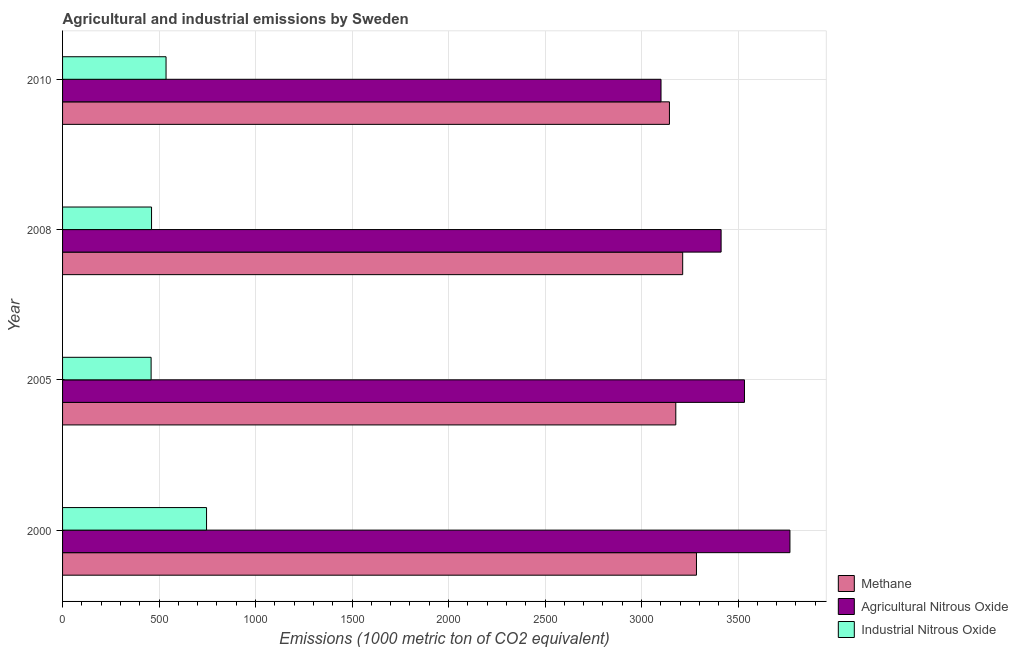How many different coloured bars are there?
Give a very brief answer. 3. How many bars are there on the 4th tick from the top?
Provide a succinct answer. 3. In how many cases, is the number of bars for a given year not equal to the number of legend labels?
Keep it short and to the point. 0. What is the amount of methane emissions in 2000?
Provide a succinct answer. 3284.7. Across all years, what is the maximum amount of industrial nitrous oxide emissions?
Provide a succinct answer. 746.1. Across all years, what is the minimum amount of methane emissions?
Offer a terse response. 3144.6. In which year was the amount of methane emissions maximum?
Offer a terse response. 2000. What is the total amount of agricultural nitrous oxide emissions in the graph?
Keep it short and to the point. 1.38e+04. What is the difference between the amount of industrial nitrous oxide emissions in 2008 and that in 2010?
Provide a short and direct response. -75.1. What is the difference between the amount of methane emissions in 2000 and the amount of agricultural nitrous oxide emissions in 2005?
Provide a succinct answer. -248.7. What is the average amount of methane emissions per year?
Provide a short and direct response. 3205.05. In the year 2010, what is the difference between the amount of industrial nitrous oxide emissions and amount of agricultural nitrous oxide emissions?
Your answer should be very brief. -2564.8. What is the ratio of the amount of agricultural nitrous oxide emissions in 2008 to that in 2010?
Offer a very short reply. 1.1. Is the amount of methane emissions in 2005 less than that in 2010?
Keep it short and to the point. No. Is the difference between the amount of industrial nitrous oxide emissions in 2005 and 2010 greater than the difference between the amount of agricultural nitrous oxide emissions in 2005 and 2010?
Your response must be concise. No. What is the difference between the highest and the second highest amount of industrial nitrous oxide emissions?
Ensure brevity in your answer.  209.9. What is the difference between the highest and the lowest amount of industrial nitrous oxide emissions?
Your answer should be very brief. 287.3. In how many years, is the amount of methane emissions greater than the average amount of methane emissions taken over all years?
Keep it short and to the point. 2. What does the 2nd bar from the top in 2005 represents?
Offer a terse response. Agricultural Nitrous Oxide. What does the 2nd bar from the bottom in 2005 represents?
Your answer should be very brief. Agricultural Nitrous Oxide. Are all the bars in the graph horizontal?
Offer a very short reply. Yes. Does the graph contain grids?
Keep it short and to the point. Yes. Where does the legend appear in the graph?
Make the answer very short. Bottom right. What is the title of the graph?
Your response must be concise. Agricultural and industrial emissions by Sweden. Does "Infant(female)" appear as one of the legend labels in the graph?
Provide a short and direct response. No. What is the label or title of the X-axis?
Your answer should be compact. Emissions (1000 metric ton of CO2 equivalent). What is the label or title of the Y-axis?
Provide a short and direct response. Year. What is the Emissions (1000 metric ton of CO2 equivalent) of Methane in 2000?
Your response must be concise. 3284.7. What is the Emissions (1000 metric ton of CO2 equivalent) in Agricultural Nitrous Oxide in 2000?
Your answer should be very brief. 3769. What is the Emissions (1000 metric ton of CO2 equivalent) in Industrial Nitrous Oxide in 2000?
Your answer should be very brief. 746.1. What is the Emissions (1000 metric ton of CO2 equivalent) in Methane in 2005?
Provide a short and direct response. 3177.6. What is the Emissions (1000 metric ton of CO2 equivalent) of Agricultural Nitrous Oxide in 2005?
Your response must be concise. 3533.4. What is the Emissions (1000 metric ton of CO2 equivalent) of Industrial Nitrous Oxide in 2005?
Give a very brief answer. 458.8. What is the Emissions (1000 metric ton of CO2 equivalent) of Methane in 2008?
Make the answer very short. 3213.3. What is the Emissions (1000 metric ton of CO2 equivalent) of Agricultural Nitrous Oxide in 2008?
Your answer should be compact. 3412.4. What is the Emissions (1000 metric ton of CO2 equivalent) in Industrial Nitrous Oxide in 2008?
Your response must be concise. 461.1. What is the Emissions (1000 metric ton of CO2 equivalent) in Methane in 2010?
Ensure brevity in your answer.  3144.6. What is the Emissions (1000 metric ton of CO2 equivalent) of Agricultural Nitrous Oxide in 2010?
Make the answer very short. 3101. What is the Emissions (1000 metric ton of CO2 equivalent) in Industrial Nitrous Oxide in 2010?
Your answer should be very brief. 536.2. Across all years, what is the maximum Emissions (1000 metric ton of CO2 equivalent) of Methane?
Your answer should be compact. 3284.7. Across all years, what is the maximum Emissions (1000 metric ton of CO2 equivalent) of Agricultural Nitrous Oxide?
Give a very brief answer. 3769. Across all years, what is the maximum Emissions (1000 metric ton of CO2 equivalent) of Industrial Nitrous Oxide?
Offer a very short reply. 746.1. Across all years, what is the minimum Emissions (1000 metric ton of CO2 equivalent) in Methane?
Give a very brief answer. 3144.6. Across all years, what is the minimum Emissions (1000 metric ton of CO2 equivalent) in Agricultural Nitrous Oxide?
Your answer should be very brief. 3101. Across all years, what is the minimum Emissions (1000 metric ton of CO2 equivalent) of Industrial Nitrous Oxide?
Provide a succinct answer. 458.8. What is the total Emissions (1000 metric ton of CO2 equivalent) in Methane in the graph?
Offer a very short reply. 1.28e+04. What is the total Emissions (1000 metric ton of CO2 equivalent) of Agricultural Nitrous Oxide in the graph?
Your answer should be compact. 1.38e+04. What is the total Emissions (1000 metric ton of CO2 equivalent) of Industrial Nitrous Oxide in the graph?
Your response must be concise. 2202.2. What is the difference between the Emissions (1000 metric ton of CO2 equivalent) of Methane in 2000 and that in 2005?
Your answer should be compact. 107.1. What is the difference between the Emissions (1000 metric ton of CO2 equivalent) of Agricultural Nitrous Oxide in 2000 and that in 2005?
Offer a very short reply. 235.6. What is the difference between the Emissions (1000 metric ton of CO2 equivalent) of Industrial Nitrous Oxide in 2000 and that in 2005?
Offer a terse response. 287.3. What is the difference between the Emissions (1000 metric ton of CO2 equivalent) of Methane in 2000 and that in 2008?
Offer a very short reply. 71.4. What is the difference between the Emissions (1000 metric ton of CO2 equivalent) in Agricultural Nitrous Oxide in 2000 and that in 2008?
Keep it short and to the point. 356.6. What is the difference between the Emissions (1000 metric ton of CO2 equivalent) of Industrial Nitrous Oxide in 2000 and that in 2008?
Offer a terse response. 285. What is the difference between the Emissions (1000 metric ton of CO2 equivalent) in Methane in 2000 and that in 2010?
Keep it short and to the point. 140.1. What is the difference between the Emissions (1000 metric ton of CO2 equivalent) in Agricultural Nitrous Oxide in 2000 and that in 2010?
Offer a very short reply. 668. What is the difference between the Emissions (1000 metric ton of CO2 equivalent) in Industrial Nitrous Oxide in 2000 and that in 2010?
Your answer should be very brief. 209.9. What is the difference between the Emissions (1000 metric ton of CO2 equivalent) of Methane in 2005 and that in 2008?
Give a very brief answer. -35.7. What is the difference between the Emissions (1000 metric ton of CO2 equivalent) of Agricultural Nitrous Oxide in 2005 and that in 2008?
Offer a terse response. 121. What is the difference between the Emissions (1000 metric ton of CO2 equivalent) in Agricultural Nitrous Oxide in 2005 and that in 2010?
Offer a very short reply. 432.4. What is the difference between the Emissions (1000 metric ton of CO2 equivalent) of Industrial Nitrous Oxide in 2005 and that in 2010?
Make the answer very short. -77.4. What is the difference between the Emissions (1000 metric ton of CO2 equivalent) in Methane in 2008 and that in 2010?
Your answer should be very brief. 68.7. What is the difference between the Emissions (1000 metric ton of CO2 equivalent) in Agricultural Nitrous Oxide in 2008 and that in 2010?
Make the answer very short. 311.4. What is the difference between the Emissions (1000 metric ton of CO2 equivalent) in Industrial Nitrous Oxide in 2008 and that in 2010?
Offer a terse response. -75.1. What is the difference between the Emissions (1000 metric ton of CO2 equivalent) of Methane in 2000 and the Emissions (1000 metric ton of CO2 equivalent) of Agricultural Nitrous Oxide in 2005?
Provide a succinct answer. -248.7. What is the difference between the Emissions (1000 metric ton of CO2 equivalent) of Methane in 2000 and the Emissions (1000 metric ton of CO2 equivalent) of Industrial Nitrous Oxide in 2005?
Ensure brevity in your answer.  2825.9. What is the difference between the Emissions (1000 metric ton of CO2 equivalent) in Agricultural Nitrous Oxide in 2000 and the Emissions (1000 metric ton of CO2 equivalent) in Industrial Nitrous Oxide in 2005?
Your answer should be very brief. 3310.2. What is the difference between the Emissions (1000 metric ton of CO2 equivalent) of Methane in 2000 and the Emissions (1000 metric ton of CO2 equivalent) of Agricultural Nitrous Oxide in 2008?
Provide a succinct answer. -127.7. What is the difference between the Emissions (1000 metric ton of CO2 equivalent) of Methane in 2000 and the Emissions (1000 metric ton of CO2 equivalent) of Industrial Nitrous Oxide in 2008?
Provide a succinct answer. 2823.6. What is the difference between the Emissions (1000 metric ton of CO2 equivalent) in Agricultural Nitrous Oxide in 2000 and the Emissions (1000 metric ton of CO2 equivalent) in Industrial Nitrous Oxide in 2008?
Ensure brevity in your answer.  3307.9. What is the difference between the Emissions (1000 metric ton of CO2 equivalent) in Methane in 2000 and the Emissions (1000 metric ton of CO2 equivalent) in Agricultural Nitrous Oxide in 2010?
Your answer should be very brief. 183.7. What is the difference between the Emissions (1000 metric ton of CO2 equivalent) in Methane in 2000 and the Emissions (1000 metric ton of CO2 equivalent) in Industrial Nitrous Oxide in 2010?
Provide a succinct answer. 2748.5. What is the difference between the Emissions (1000 metric ton of CO2 equivalent) of Agricultural Nitrous Oxide in 2000 and the Emissions (1000 metric ton of CO2 equivalent) of Industrial Nitrous Oxide in 2010?
Keep it short and to the point. 3232.8. What is the difference between the Emissions (1000 metric ton of CO2 equivalent) of Methane in 2005 and the Emissions (1000 metric ton of CO2 equivalent) of Agricultural Nitrous Oxide in 2008?
Your answer should be very brief. -234.8. What is the difference between the Emissions (1000 metric ton of CO2 equivalent) in Methane in 2005 and the Emissions (1000 metric ton of CO2 equivalent) in Industrial Nitrous Oxide in 2008?
Ensure brevity in your answer.  2716.5. What is the difference between the Emissions (1000 metric ton of CO2 equivalent) of Agricultural Nitrous Oxide in 2005 and the Emissions (1000 metric ton of CO2 equivalent) of Industrial Nitrous Oxide in 2008?
Offer a very short reply. 3072.3. What is the difference between the Emissions (1000 metric ton of CO2 equivalent) of Methane in 2005 and the Emissions (1000 metric ton of CO2 equivalent) of Agricultural Nitrous Oxide in 2010?
Ensure brevity in your answer.  76.6. What is the difference between the Emissions (1000 metric ton of CO2 equivalent) in Methane in 2005 and the Emissions (1000 metric ton of CO2 equivalent) in Industrial Nitrous Oxide in 2010?
Provide a succinct answer. 2641.4. What is the difference between the Emissions (1000 metric ton of CO2 equivalent) of Agricultural Nitrous Oxide in 2005 and the Emissions (1000 metric ton of CO2 equivalent) of Industrial Nitrous Oxide in 2010?
Keep it short and to the point. 2997.2. What is the difference between the Emissions (1000 metric ton of CO2 equivalent) of Methane in 2008 and the Emissions (1000 metric ton of CO2 equivalent) of Agricultural Nitrous Oxide in 2010?
Provide a short and direct response. 112.3. What is the difference between the Emissions (1000 metric ton of CO2 equivalent) of Methane in 2008 and the Emissions (1000 metric ton of CO2 equivalent) of Industrial Nitrous Oxide in 2010?
Offer a very short reply. 2677.1. What is the difference between the Emissions (1000 metric ton of CO2 equivalent) of Agricultural Nitrous Oxide in 2008 and the Emissions (1000 metric ton of CO2 equivalent) of Industrial Nitrous Oxide in 2010?
Your answer should be compact. 2876.2. What is the average Emissions (1000 metric ton of CO2 equivalent) of Methane per year?
Provide a short and direct response. 3205.05. What is the average Emissions (1000 metric ton of CO2 equivalent) in Agricultural Nitrous Oxide per year?
Keep it short and to the point. 3453.95. What is the average Emissions (1000 metric ton of CO2 equivalent) of Industrial Nitrous Oxide per year?
Make the answer very short. 550.55. In the year 2000, what is the difference between the Emissions (1000 metric ton of CO2 equivalent) in Methane and Emissions (1000 metric ton of CO2 equivalent) in Agricultural Nitrous Oxide?
Provide a short and direct response. -484.3. In the year 2000, what is the difference between the Emissions (1000 metric ton of CO2 equivalent) in Methane and Emissions (1000 metric ton of CO2 equivalent) in Industrial Nitrous Oxide?
Your answer should be compact. 2538.6. In the year 2000, what is the difference between the Emissions (1000 metric ton of CO2 equivalent) of Agricultural Nitrous Oxide and Emissions (1000 metric ton of CO2 equivalent) of Industrial Nitrous Oxide?
Make the answer very short. 3022.9. In the year 2005, what is the difference between the Emissions (1000 metric ton of CO2 equivalent) in Methane and Emissions (1000 metric ton of CO2 equivalent) in Agricultural Nitrous Oxide?
Offer a terse response. -355.8. In the year 2005, what is the difference between the Emissions (1000 metric ton of CO2 equivalent) of Methane and Emissions (1000 metric ton of CO2 equivalent) of Industrial Nitrous Oxide?
Offer a very short reply. 2718.8. In the year 2005, what is the difference between the Emissions (1000 metric ton of CO2 equivalent) of Agricultural Nitrous Oxide and Emissions (1000 metric ton of CO2 equivalent) of Industrial Nitrous Oxide?
Your answer should be compact. 3074.6. In the year 2008, what is the difference between the Emissions (1000 metric ton of CO2 equivalent) of Methane and Emissions (1000 metric ton of CO2 equivalent) of Agricultural Nitrous Oxide?
Your response must be concise. -199.1. In the year 2008, what is the difference between the Emissions (1000 metric ton of CO2 equivalent) in Methane and Emissions (1000 metric ton of CO2 equivalent) in Industrial Nitrous Oxide?
Provide a succinct answer. 2752.2. In the year 2008, what is the difference between the Emissions (1000 metric ton of CO2 equivalent) in Agricultural Nitrous Oxide and Emissions (1000 metric ton of CO2 equivalent) in Industrial Nitrous Oxide?
Provide a succinct answer. 2951.3. In the year 2010, what is the difference between the Emissions (1000 metric ton of CO2 equivalent) of Methane and Emissions (1000 metric ton of CO2 equivalent) of Agricultural Nitrous Oxide?
Provide a succinct answer. 43.6. In the year 2010, what is the difference between the Emissions (1000 metric ton of CO2 equivalent) in Methane and Emissions (1000 metric ton of CO2 equivalent) in Industrial Nitrous Oxide?
Provide a succinct answer. 2608.4. In the year 2010, what is the difference between the Emissions (1000 metric ton of CO2 equivalent) of Agricultural Nitrous Oxide and Emissions (1000 metric ton of CO2 equivalent) of Industrial Nitrous Oxide?
Offer a very short reply. 2564.8. What is the ratio of the Emissions (1000 metric ton of CO2 equivalent) of Methane in 2000 to that in 2005?
Keep it short and to the point. 1.03. What is the ratio of the Emissions (1000 metric ton of CO2 equivalent) of Agricultural Nitrous Oxide in 2000 to that in 2005?
Provide a succinct answer. 1.07. What is the ratio of the Emissions (1000 metric ton of CO2 equivalent) of Industrial Nitrous Oxide in 2000 to that in 2005?
Your response must be concise. 1.63. What is the ratio of the Emissions (1000 metric ton of CO2 equivalent) of Methane in 2000 to that in 2008?
Provide a short and direct response. 1.02. What is the ratio of the Emissions (1000 metric ton of CO2 equivalent) in Agricultural Nitrous Oxide in 2000 to that in 2008?
Make the answer very short. 1.1. What is the ratio of the Emissions (1000 metric ton of CO2 equivalent) of Industrial Nitrous Oxide in 2000 to that in 2008?
Provide a short and direct response. 1.62. What is the ratio of the Emissions (1000 metric ton of CO2 equivalent) in Methane in 2000 to that in 2010?
Your answer should be compact. 1.04. What is the ratio of the Emissions (1000 metric ton of CO2 equivalent) of Agricultural Nitrous Oxide in 2000 to that in 2010?
Provide a succinct answer. 1.22. What is the ratio of the Emissions (1000 metric ton of CO2 equivalent) of Industrial Nitrous Oxide in 2000 to that in 2010?
Provide a short and direct response. 1.39. What is the ratio of the Emissions (1000 metric ton of CO2 equivalent) of Methane in 2005 to that in 2008?
Your answer should be compact. 0.99. What is the ratio of the Emissions (1000 metric ton of CO2 equivalent) in Agricultural Nitrous Oxide in 2005 to that in 2008?
Make the answer very short. 1.04. What is the ratio of the Emissions (1000 metric ton of CO2 equivalent) in Methane in 2005 to that in 2010?
Offer a very short reply. 1.01. What is the ratio of the Emissions (1000 metric ton of CO2 equivalent) in Agricultural Nitrous Oxide in 2005 to that in 2010?
Offer a very short reply. 1.14. What is the ratio of the Emissions (1000 metric ton of CO2 equivalent) in Industrial Nitrous Oxide in 2005 to that in 2010?
Your answer should be compact. 0.86. What is the ratio of the Emissions (1000 metric ton of CO2 equivalent) in Methane in 2008 to that in 2010?
Your response must be concise. 1.02. What is the ratio of the Emissions (1000 metric ton of CO2 equivalent) of Agricultural Nitrous Oxide in 2008 to that in 2010?
Offer a terse response. 1.1. What is the ratio of the Emissions (1000 metric ton of CO2 equivalent) of Industrial Nitrous Oxide in 2008 to that in 2010?
Ensure brevity in your answer.  0.86. What is the difference between the highest and the second highest Emissions (1000 metric ton of CO2 equivalent) in Methane?
Ensure brevity in your answer.  71.4. What is the difference between the highest and the second highest Emissions (1000 metric ton of CO2 equivalent) of Agricultural Nitrous Oxide?
Provide a short and direct response. 235.6. What is the difference between the highest and the second highest Emissions (1000 metric ton of CO2 equivalent) of Industrial Nitrous Oxide?
Your answer should be very brief. 209.9. What is the difference between the highest and the lowest Emissions (1000 metric ton of CO2 equivalent) in Methane?
Your answer should be compact. 140.1. What is the difference between the highest and the lowest Emissions (1000 metric ton of CO2 equivalent) of Agricultural Nitrous Oxide?
Provide a short and direct response. 668. What is the difference between the highest and the lowest Emissions (1000 metric ton of CO2 equivalent) in Industrial Nitrous Oxide?
Offer a terse response. 287.3. 